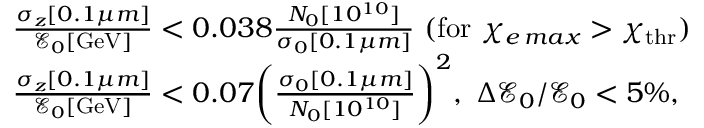Convert formula to latex. <formula><loc_0><loc_0><loc_500><loc_500>\begin{array} { r l } & { \frac { \sigma _ { z } [ 0 . 1 \mu m ] } { \mathcal { E } _ { 0 } [ G e V ] } < 0 . 0 3 8 \frac { N _ { 0 } [ 1 0 ^ { 1 0 } ] } { \sigma _ { 0 } [ 0 . 1 \mu m ] } \ ( f o r \ \chi _ { e \, \max } > \chi _ { t h r } ) } \\ & { \frac { \sigma _ { z } [ 0 . 1 \mu m ] } { \mathcal { E } _ { 0 } [ G e V ] } < 0 . 0 7 \left ( \frac { \sigma _ { 0 } [ 0 . 1 \mu m ] } { N _ { 0 } [ 1 0 ^ { 1 0 } ] } \right ) ^ { 2 } , \ \Delta \mathcal { E } _ { 0 } / \mathcal { E } _ { 0 } < 5 \% , } \end{array}</formula> 